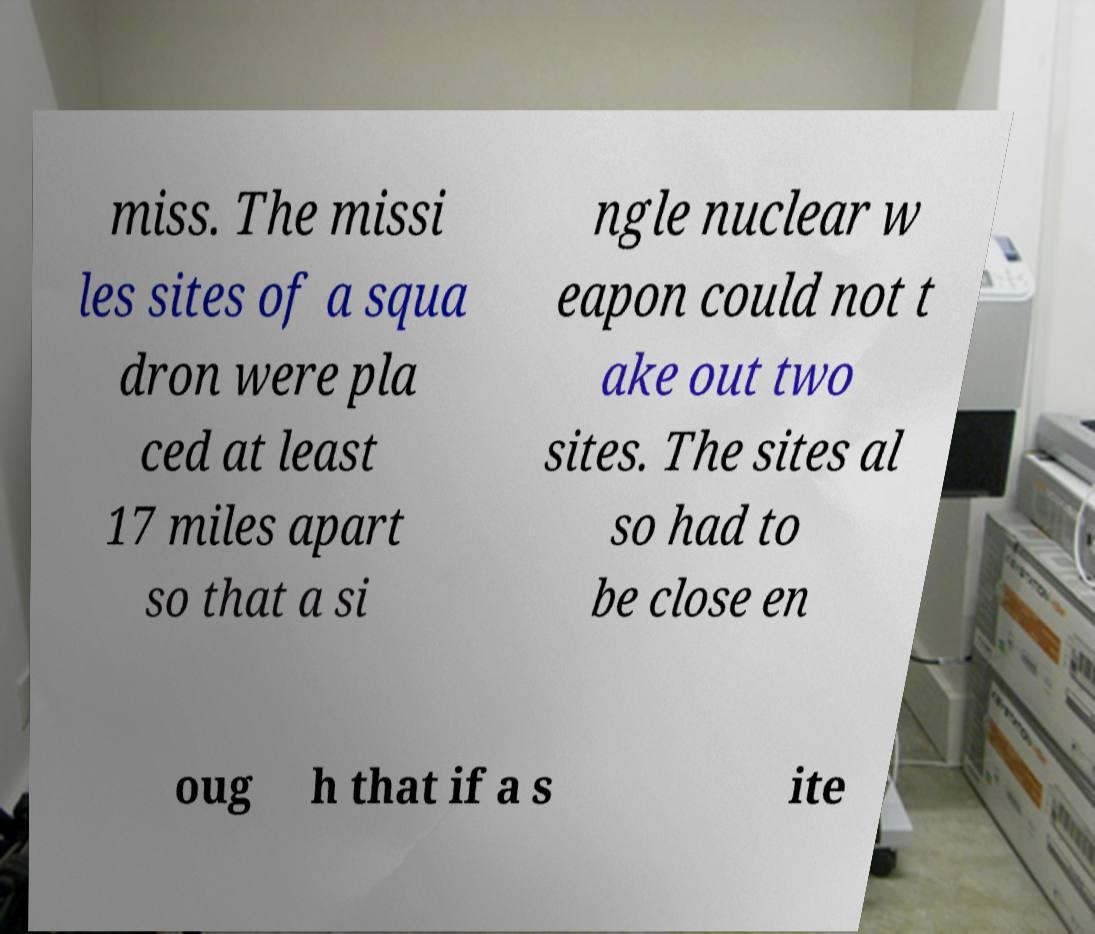I need the written content from this picture converted into text. Can you do that? miss. The missi les sites of a squa dron were pla ced at least 17 miles apart so that a si ngle nuclear w eapon could not t ake out two sites. The sites al so had to be close en oug h that if a s ite 